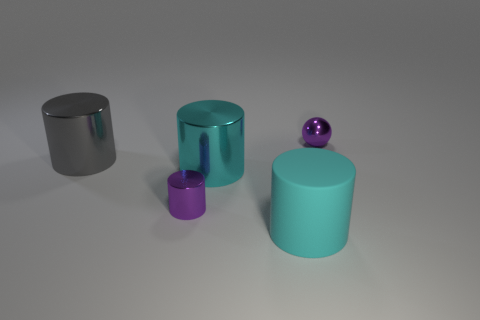How many things are either large cyan objects in front of the small cylinder or small objects that are on the left side of the sphere?
Your answer should be very brief. 2. How many other things are there of the same shape as the large cyan matte thing?
Make the answer very short. 3. Does the metallic thing that is on the right side of the large rubber thing have the same color as the tiny shiny cylinder?
Make the answer very short. Yes. What number of other things are there of the same size as the matte thing?
Provide a succinct answer. 2. Is the gray thing made of the same material as the purple cylinder?
Provide a short and direct response. Yes. There is a tiny metallic thing to the left of the tiny object right of the large matte object; what is its color?
Your response must be concise. Purple. There is a gray metal object that is the same shape as the matte object; what size is it?
Provide a short and direct response. Large. Is the tiny cylinder the same color as the sphere?
Ensure brevity in your answer.  Yes. There is a large metallic object that is right of the shiny cylinder that is behind the cyan metallic cylinder; what number of tiny purple metallic cylinders are behind it?
Keep it short and to the point. 0. Is the number of gray cylinders greater than the number of metallic objects?
Provide a short and direct response. No. 